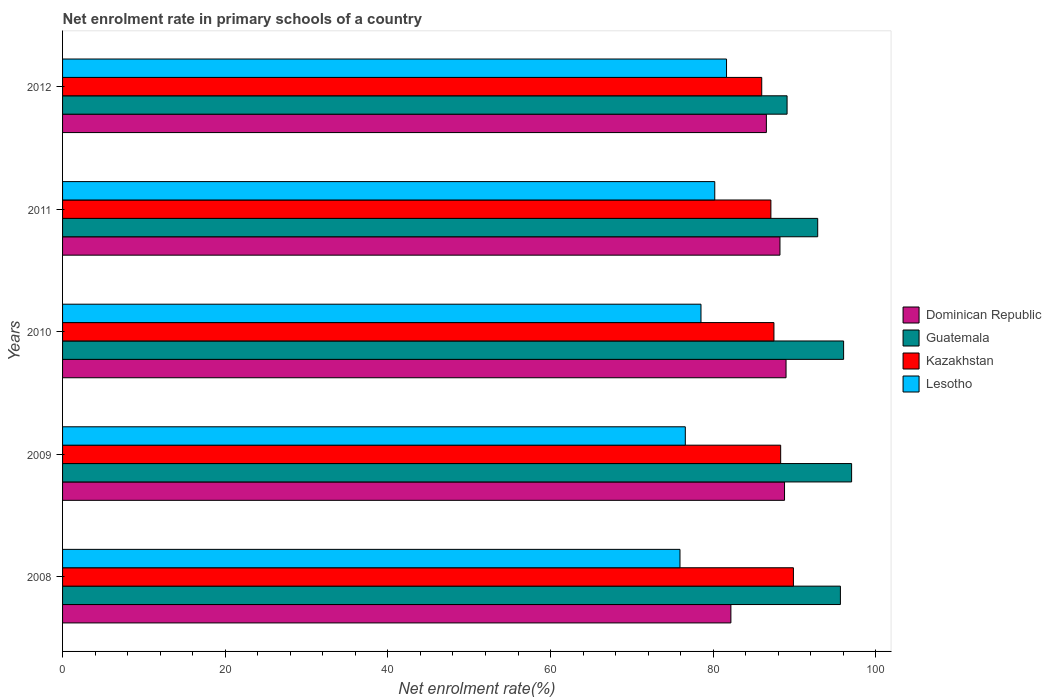How many different coloured bars are there?
Your response must be concise. 4. Are the number of bars on each tick of the Y-axis equal?
Keep it short and to the point. Yes. How many bars are there on the 1st tick from the top?
Your response must be concise. 4. How many bars are there on the 2nd tick from the bottom?
Your response must be concise. 4. In how many cases, is the number of bars for a given year not equal to the number of legend labels?
Offer a very short reply. 0. What is the net enrolment rate in primary schools in Lesotho in 2011?
Ensure brevity in your answer.  80.19. Across all years, what is the maximum net enrolment rate in primary schools in Guatemala?
Your answer should be very brief. 97.01. Across all years, what is the minimum net enrolment rate in primary schools in Guatemala?
Give a very brief answer. 89.08. What is the total net enrolment rate in primary schools in Guatemala in the graph?
Offer a very short reply. 470.59. What is the difference between the net enrolment rate in primary schools in Lesotho in 2010 and that in 2011?
Your answer should be compact. -1.69. What is the difference between the net enrolment rate in primary schools in Kazakhstan in 2011 and the net enrolment rate in primary schools in Lesotho in 2012?
Make the answer very short. 5.45. What is the average net enrolment rate in primary schools in Dominican Republic per year?
Your answer should be very brief. 86.92. In the year 2012, what is the difference between the net enrolment rate in primary schools in Guatemala and net enrolment rate in primary schools in Dominican Republic?
Ensure brevity in your answer.  2.55. In how many years, is the net enrolment rate in primary schools in Lesotho greater than 20 %?
Provide a succinct answer. 5. What is the ratio of the net enrolment rate in primary schools in Kazakhstan in 2008 to that in 2012?
Give a very brief answer. 1.05. Is the net enrolment rate in primary schools in Kazakhstan in 2010 less than that in 2011?
Make the answer very short. No. Is the difference between the net enrolment rate in primary schools in Guatemala in 2008 and 2011 greater than the difference between the net enrolment rate in primary schools in Dominican Republic in 2008 and 2011?
Ensure brevity in your answer.  Yes. What is the difference between the highest and the second highest net enrolment rate in primary schools in Lesotho?
Your response must be concise. 1.45. What is the difference between the highest and the lowest net enrolment rate in primary schools in Lesotho?
Ensure brevity in your answer.  5.72. Is the sum of the net enrolment rate in primary schools in Kazakhstan in 2010 and 2012 greater than the maximum net enrolment rate in primary schools in Guatemala across all years?
Keep it short and to the point. Yes. What does the 4th bar from the top in 2010 represents?
Provide a short and direct response. Dominican Republic. What does the 2nd bar from the bottom in 2010 represents?
Give a very brief answer. Guatemala. How many bars are there?
Make the answer very short. 20. How many years are there in the graph?
Offer a terse response. 5. Does the graph contain any zero values?
Give a very brief answer. No. Does the graph contain grids?
Keep it short and to the point. No. Where does the legend appear in the graph?
Your answer should be compact. Center right. How are the legend labels stacked?
Your response must be concise. Vertical. What is the title of the graph?
Keep it short and to the point. Net enrolment rate in primary schools of a country. What is the label or title of the X-axis?
Your answer should be compact. Net enrolment rate(%). What is the label or title of the Y-axis?
Keep it short and to the point. Years. What is the Net enrolment rate(%) in Dominican Republic in 2008?
Offer a terse response. 82.17. What is the Net enrolment rate(%) of Guatemala in 2008?
Ensure brevity in your answer.  95.63. What is the Net enrolment rate(%) in Kazakhstan in 2008?
Your answer should be compact. 89.86. What is the Net enrolment rate(%) of Lesotho in 2008?
Make the answer very short. 75.91. What is the Net enrolment rate(%) in Dominican Republic in 2009?
Ensure brevity in your answer.  88.76. What is the Net enrolment rate(%) in Guatemala in 2009?
Provide a short and direct response. 97.01. What is the Net enrolment rate(%) in Kazakhstan in 2009?
Provide a succinct answer. 88.29. What is the Net enrolment rate(%) of Lesotho in 2009?
Keep it short and to the point. 76.57. What is the Net enrolment rate(%) in Dominican Republic in 2010?
Offer a terse response. 88.95. What is the Net enrolment rate(%) of Guatemala in 2010?
Give a very brief answer. 96.03. What is the Net enrolment rate(%) in Kazakhstan in 2010?
Provide a succinct answer. 87.46. What is the Net enrolment rate(%) of Lesotho in 2010?
Your answer should be very brief. 78.49. What is the Net enrolment rate(%) of Dominican Republic in 2011?
Make the answer very short. 88.2. What is the Net enrolment rate(%) of Guatemala in 2011?
Keep it short and to the point. 92.84. What is the Net enrolment rate(%) of Kazakhstan in 2011?
Provide a short and direct response. 87.09. What is the Net enrolment rate(%) in Lesotho in 2011?
Your answer should be very brief. 80.19. What is the Net enrolment rate(%) in Dominican Republic in 2012?
Keep it short and to the point. 86.53. What is the Net enrolment rate(%) in Guatemala in 2012?
Your answer should be very brief. 89.08. What is the Net enrolment rate(%) in Kazakhstan in 2012?
Offer a terse response. 85.96. What is the Net enrolment rate(%) in Lesotho in 2012?
Offer a terse response. 81.63. Across all years, what is the maximum Net enrolment rate(%) in Dominican Republic?
Offer a very short reply. 88.95. Across all years, what is the maximum Net enrolment rate(%) of Guatemala?
Your answer should be very brief. 97.01. Across all years, what is the maximum Net enrolment rate(%) of Kazakhstan?
Your response must be concise. 89.86. Across all years, what is the maximum Net enrolment rate(%) of Lesotho?
Offer a very short reply. 81.63. Across all years, what is the minimum Net enrolment rate(%) of Dominican Republic?
Offer a very short reply. 82.17. Across all years, what is the minimum Net enrolment rate(%) in Guatemala?
Your answer should be very brief. 89.08. Across all years, what is the minimum Net enrolment rate(%) of Kazakhstan?
Ensure brevity in your answer.  85.96. Across all years, what is the minimum Net enrolment rate(%) in Lesotho?
Offer a very short reply. 75.91. What is the total Net enrolment rate(%) of Dominican Republic in the graph?
Your answer should be very brief. 434.62. What is the total Net enrolment rate(%) in Guatemala in the graph?
Offer a terse response. 470.59. What is the total Net enrolment rate(%) in Kazakhstan in the graph?
Ensure brevity in your answer.  438.65. What is the total Net enrolment rate(%) of Lesotho in the graph?
Keep it short and to the point. 392.79. What is the difference between the Net enrolment rate(%) in Dominican Republic in 2008 and that in 2009?
Keep it short and to the point. -6.6. What is the difference between the Net enrolment rate(%) in Guatemala in 2008 and that in 2009?
Offer a terse response. -1.38. What is the difference between the Net enrolment rate(%) in Kazakhstan in 2008 and that in 2009?
Your answer should be compact. 1.57. What is the difference between the Net enrolment rate(%) of Lesotho in 2008 and that in 2009?
Provide a succinct answer. -0.65. What is the difference between the Net enrolment rate(%) in Dominican Republic in 2008 and that in 2010?
Provide a succinct answer. -6.78. What is the difference between the Net enrolment rate(%) of Guatemala in 2008 and that in 2010?
Provide a succinct answer. -0.39. What is the difference between the Net enrolment rate(%) of Kazakhstan in 2008 and that in 2010?
Keep it short and to the point. 2.4. What is the difference between the Net enrolment rate(%) of Lesotho in 2008 and that in 2010?
Give a very brief answer. -2.58. What is the difference between the Net enrolment rate(%) in Dominican Republic in 2008 and that in 2011?
Ensure brevity in your answer.  -6.03. What is the difference between the Net enrolment rate(%) in Guatemala in 2008 and that in 2011?
Give a very brief answer. 2.79. What is the difference between the Net enrolment rate(%) in Kazakhstan in 2008 and that in 2011?
Give a very brief answer. 2.77. What is the difference between the Net enrolment rate(%) in Lesotho in 2008 and that in 2011?
Provide a short and direct response. -4.28. What is the difference between the Net enrolment rate(%) in Dominican Republic in 2008 and that in 2012?
Keep it short and to the point. -4.36. What is the difference between the Net enrolment rate(%) of Guatemala in 2008 and that in 2012?
Your answer should be very brief. 6.56. What is the difference between the Net enrolment rate(%) in Kazakhstan in 2008 and that in 2012?
Give a very brief answer. 3.9. What is the difference between the Net enrolment rate(%) of Lesotho in 2008 and that in 2012?
Provide a short and direct response. -5.72. What is the difference between the Net enrolment rate(%) of Dominican Republic in 2009 and that in 2010?
Offer a terse response. -0.19. What is the difference between the Net enrolment rate(%) of Guatemala in 2009 and that in 2010?
Offer a very short reply. 0.98. What is the difference between the Net enrolment rate(%) in Kazakhstan in 2009 and that in 2010?
Your response must be concise. 0.83. What is the difference between the Net enrolment rate(%) of Lesotho in 2009 and that in 2010?
Offer a very short reply. -1.93. What is the difference between the Net enrolment rate(%) of Dominican Republic in 2009 and that in 2011?
Your answer should be compact. 0.56. What is the difference between the Net enrolment rate(%) of Guatemala in 2009 and that in 2011?
Your answer should be compact. 4.17. What is the difference between the Net enrolment rate(%) of Kazakhstan in 2009 and that in 2011?
Give a very brief answer. 1.2. What is the difference between the Net enrolment rate(%) of Lesotho in 2009 and that in 2011?
Offer a terse response. -3.62. What is the difference between the Net enrolment rate(%) of Dominican Republic in 2009 and that in 2012?
Keep it short and to the point. 2.23. What is the difference between the Net enrolment rate(%) in Guatemala in 2009 and that in 2012?
Provide a short and direct response. 7.93. What is the difference between the Net enrolment rate(%) in Kazakhstan in 2009 and that in 2012?
Your answer should be very brief. 2.33. What is the difference between the Net enrolment rate(%) of Lesotho in 2009 and that in 2012?
Your answer should be compact. -5.07. What is the difference between the Net enrolment rate(%) in Dominican Republic in 2010 and that in 2011?
Your answer should be very brief. 0.75. What is the difference between the Net enrolment rate(%) of Guatemala in 2010 and that in 2011?
Your response must be concise. 3.19. What is the difference between the Net enrolment rate(%) of Kazakhstan in 2010 and that in 2011?
Make the answer very short. 0.37. What is the difference between the Net enrolment rate(%) of Lesotho in 2010 and that in 2011?
Your answer should be very brief. -1.69. What is the difference between the Net enrolment rate(%) in Dominican Republic in 2010 and that in 2012?
Keep it short and to the point. 2.42. What is the difference between the Net enrolment rate(%) of Guatemala in 2010 and that in 2012?
Your answer should be compact. 6.95. What is the difference between the Net enrolment rate(%) in Kazakhstan in 2010 and that in 2012?
Keep it short and to the point. 1.5. What is the difference between the Net enrolment rate(%) in Lesotho in 2010 and that in 2012?
Provide a succinct answer. -3.14. What is the difference between the Net enrolment rate(%) of Dominican Republic in 2011 and that in 2012?
Offer a very short reply. 1.67. What is the difference between the Net enrolment rate(%) of Guatemala in 2011 and that in 2012?
Provide a succinct answer. 3.76. What is the difference between the Net enrolment rate(%) of Kazakhstan in 2011 and that in 2012?
Keep it short and to the point. 1.13. What is the difference between the Net enrolment rate(%) in Lesotho in 2011 and that in 2012?
Provide a succinct answer. -1.45. What is the difference between the Net enrolment rate(%) of Dominican Republic in 2008 and the Net enrolment rate(%) of Guatemala in 2009?
Offer a very short reply. -14.84. What is the difference between the Net enrolment rate(%) in Dominican Republic in 2008 and the Net enrolment rate(%) in Kazakhstan in 2009?
Give a very brief answer. -6.12. What is the difference between the Net enrolment rate(%) of Dominican Republic in 2008 and the Net enrolment rate(%) of Lesotho in 2009?
Ensure brevity in your answer.  5.6. What is the difference between the Net enrolment rate(%) in Guatemala in 2008 and the Net enrolment rate(%) in Kazakhstan in 2009?
Your answer should be compact. 7.34. What is the difference between the Net enrolment rate(%) of Guatemala in 2008 and the Net enrolment rate(%) of Lesotho in 2009?
Offer a terse response. 19.07. What is the difference between the Net enrolment rate(%) of Kazakhstan in 2008 and the Net enrolment rate(%) of Lesotho in 2009?
Ensure brevity in your answer.  13.29. What is the difference between the Net enrolment rate(%) in Dominican Republic in 2008 and the Net enrolment rate(%) in Guatemala in 2010?
Your response must be concise. -13.86. What is the difference between the Net enrolment rate(%) of Dominican Republic in 2008 and the Net enrolment rate(%) of Kazakhstan in 2010?
Offer a terse response. -5.29. What is the difference between the Net enrolment rate(%) of Dominican Republic in 2008 and the Net enrolment rate(%) of Lesotho in 2010?
Ensure brevity in your answer.  3.68. What is the difference between the Net enrolment rate(%) in Guatemala in 2008 and the Net enrolment rate(%) in Kazakhstan in 2010?
Make the answer very short. 8.17. What is the difference between the Net enrolment rate(%) in Guatemala in 2008 and the Net enrolment rate(%) in Lesotho in 2010?
Your answer should be very brief. 17.14. What is the difference between the Net enrolment rate(%) of Kazakhstan in 2008 and the Net enrolment rate(%) of Lesotho in 2010?
Provide a succinct answer. 11.36. What is the difference between the Net enrolment rate(%) in Dominican Republic in 2008 and the Net enrolment rate(%) in Guatemala in 2011?
Keep it short and to the point. -10.67. What is the difference between the Net enrolment rate(%) of Dominican Republic in 2008 and the Net enrolment rate(%) of Kazakhstan in 2011?
Keep it short and to the point. -4.92. What is the difference between the Net enrolment rate(%) of Dominican Republic in 2008 and the Net enrolment rate(%) of Lesotho in 2011?
Keep it short and to the point. 1.98. What is the difference between the Net enrolment rate(%) in Guatemala in 2008 and the Net enrolment rate(%) in Kazakhstan in 2011?
Offer a terse response. 8.55. What is the difference between the Net enrolment rate(%) in Guatemala in 2008 and the Net enrolment rate(%) in Lesotho in 2011?
Provide a short and direct response. 15.45. What is the difference between the Net enrolment rate(%) in Kazakhstan in 2008 and the Net enrolment rate(%) in Lesotho in 2011?
Give a very brief answer. 9.67. What is the difference between the Net enrolment rate(%) in Dominican Republic in 2008 and the Net enrolment rate(%) in Guatemala in 2012?
Offer a very short reply. -6.91. What is the difference between the Net enrolment rate(%) of Dominican Republic in 2008 and the Net enrolment rate(%) of Kazakhstan in 2012?
Give a very brief answer. -3.79. What is the difference between the Net enrolment rate(%) in Dominican Republic in 2008 and the Net enrolment rate(%) in Lesotho in 2012?
Offer a very short reply. 0.53. What is the difference between the Net enrolment rate(%) of Guatemala in 2008 and the Net enrolment rate(%) of Kazakhstan in 2012?
Your answer should be very brief. 9.67. What is the difference between the Net enrolment rate(%) in Guatemala in 2008 and the Net enrolment rate(%) in Lesotho in 2012?
Your response must be concise. 14. What is the difference between the Net enrolment rate(%) of Kazakhstan in 2008 and the Net enrolment rate(%) of Lesotho in 2012?
Ensure brevity in your answer.  8.22. What is the difference between the Net enrolment rate(%) of Dominican Republic in 2009 and the Net enrolment rate(%) of Guatemala in 2010?
Give a very brief answer. -7.26. What is the difference between the Net enrolment rate(%) of Dominican Republic in 2009 and the Net enrolment rate(%) of Kazakhstan in 2010?
Provide a short and direct response. 1.3. What is the difference between the Net enrolment rate(%) in Dominican Republic in 2009 and the Net enrolment rate(%) in Lesotho in 2010?
Give a very brief answer. 10.27. What is the difference between the Net enrolment rate(%) of Guatemala in 2009 and the Net enrolment rate(%) of Kazakhstan in 2010?
Make the answer very short. 9.55. What is the difference between the Net enrolment rate(%) of Guatemala in 2009 and the Net enrolment rate(%) of Lesotho in 2010?
Your answer should be compact. 18.52. What is the difference between the Net enrolment rate(%) in Kazakhstan in 2009 and the Net enrolment rate(%) in Lesotho in 2010?
Your answer should be compact. 9.8. What is the difference between the Net enrolment rate(%) in Dominican Republic in 2009 and the Net enrolment rate(%) in Guatemala in 2011?
Provide a short and direct response. -4.08. What is the difference between the Net enrolment rate(%) in Dominican Republic in 2009 and the Net enrolment rate(%) in Kazakhstan in 2011?
Make the answer very short. 1.68. What is the difference between the Net enrolment rate(%) of Dominican Republic in 2009 and the Net enrolment rate(%) of Lesotho in 2011?
Your answer should be compact. 8.58. What is the difference between the Net enrolment rate(%) of Guatemala in 2009 and the Net enrolment rate(%) of Kazakhstan in 2011?
Your response must be concise. 9.92. What is the difference between the Net enrolment rate(%) in Guatemala in 2009 and the Net enrolment rate(%) in Lesotho in 2011?
Offer a terse response. 16.82. What is the difference between the Net enrolment rate(%) of Kazakhstan in 2009 and the Net enrolment rate(%) of Lesotho in 2011?
Provide a short and direct response. 8.1. What is the difference between the Net enrolment rate(%) in Dominican Republic in 2009 and the Net enrolment rate(%) in Guatemala in 2012?
Offer a terse response. -0.31. What is the difference between the Net enrolment rate(%) in Dominican Republic in 2009 and the Net enrolment rate(%) in Kazakhstan in 2012?
Ensure brevity in your answer.  2.8. What is the difference between the Net enrolment rate(%) of Dominican Republic in 2009 and the Net enrolment rate(%) of Lesotho in 2012?
Give a very brief answer. 7.13. What is the difference between the Net enrolment rate(%) in Guatemala in 2009 and the Net enrolment rate(%) in Kazakhstan in 2012?
Your answer should be very brief. 11.05. What is the difference between the Net enrolment rate(%) of Guatemala in 2009 and the Net enrolment rate(%) of Lesotho in 2012?
Give a very brief answer. 15.38. What is the difference between the Net enrolment rate(%) in Kazakhstan in 2009 and the Net enrolment rate(%) in Lesotho in 2012?
Ensure brevity in your answer.  6.66. What is the difference between the Net enrolment rate(%) in Dominican Republic in 2010 and the Net enrolment rate(%) in Guatemala in 2011?
Offer a terse response. -3.89. What is the difference between the Net enrolment rate(%) in Dominican Republic in 2010 and the Net enrolment rate(%) in Kazakhstan in 2011?
Provide a succinct answer. 1.86. What is the difference between the Net enrolment rate(%) in Dominican Republic in 2010 and the Net enrolment rate(%) in Lesotho in 2011?
Make the answer very short. 8.76. What is the difference between the Net enrolment rate(%) in Guatemala in 2010 and the Net enrolment rate(%) in Kazakhstan in 2011?
Your answer should be very brief. 8.94. What is the difference between the Net enrolment rate(%) in Guatemala in 2010 and the Net enrolment rate(%) in Lesotho in 2011?
Your response must be concise. 15.84. What is the difference between the Net enrolment rate(%) in Kazakhstan in 2010 and the Net enrolment rate(%) in Lesotho in 2011?
Your answer should be compact. 7.27. What is the difference between the Net enrolment rate(%) in Dominican Republic in 2010 and the Net enrolment rate(%) in Guatemala in 2012?
Make the answer very short. -0.13. What is the difference between the Net enrolment rate(%) in Dominican Republic in 2010 and the Net enrolment rate(%) in Kazakhstan in 2012?
Give a very brief answer. 2.99. What is the difference between the Net enrolment rate(%) of Dominican Republic in 2010 and the Net enrolment rate(%) of Lesotho in 2012?
Offer a terse response. 7.32. What is the difference between the Net enrolment rate(%) in Guatemala in 2010 and the Net enrolment rate(%) in Kazakhstan in 2012?
Ensure brevity in your answer.  10.07. What is the difference between the Net enrolment rate(%) of Guatemala in 2010 and the Net enrolment rate(%) of Lesotho in 2012?
Your answer should be compact. 14.39. What is the difference between the Net enrolment rate(%) in Kazakhstan in 2010 and the Net enrolment rate(%) in Lesotho in 2012?
Provide a short and direct response. 5.83. What is the difference between the Net enrolment rate(%) in Dominican Republic in 2011 and the Net enrolment rate(%) in Guatemala in 2012?
Keep it short and to the point. -0.88. What is the difference between the Net enrolment rate(%) in Dominican Republic in 2011 and the Net enrolment rate(%) in Kazakhstan in 2012?
Ensure brevity in your answer.  2.24. What is the difference between the Net enrolment rate(%) of Dominican Republic in 2011 and the Net enrolment rate(%) of Lesotho in 2012?
Ensure brevity in your answer.  6.57. What is the difference between the Net enrolment rate(%) of Guatemala in 2011 and the Net enrolment rate(%) of Kazakhstan in 2012?
Your response must be concise. 6.88. What is the difference between the Net enrolment rate(%) in Guatemala in 2011 and the Net enrolment rate(%) in Lesotho in 2012?
Ensure brevity in your answer.  11.21. What is the difference between the Net enrolment rate(%) of Kazakhstan in 2011 and the Net enrolment rate(%) of Lesotho in 2012?
Your answer should be very brief. 5.45. What is the average Net enrolment rate(%) of Dominican Republic per year?
Your answer should be very brief. 86.92. What is the average Net enrolment rate(%) in Guatemala per year?
Make the answer very short. 94.12. What is the average Net enrolment rate(%) in Kazakhstan per year?
Offer a terse response. 87.73. What is the average Net enrolment rate(%) of Lesotho per year?
Your answer should be compact. 78.56. In the year 2008, what is the difference between the Net enrolment rate(%) of Dominican Republic and Net enrolment rate(%) of Guatemala?
Offer a terse response. -13.47. In the year 2008, what is the difference between the Net enrolment rate(%) of Dominican Republic and Net enrolment rate(%) of Kazakhstan?
Keep it short and to the point. -7.69. In the year 2008, what is the difference between the Net enrolment rate(%) in Dominican Republic and Net enrolment rate(%) in Lesotho?
Offer a very short reply. 6.26. In the year 2008, what is the difference between the Net enrolment rate(%) of Guatemala and Net enrolment rate(%) of Kazakhstan?
Your response must be concise. 5.78. In the year 2008, what is the difference between the Net enrolment rate(%) in Guatemala and Net enrolment rate(%) in Lesotho?
Your answer should be very brief. 19.72. In the year 2008, what is the difference between the Net enrolment rate(%) of Kazakhstan and Net enrolment rate(%) of Lesotho?
Your answer should be compact. 13.95. In the year 2009, what is the difference between the Net enrolment rate(%) of Dominican Republic and Net enrolment rate(%) of Guatemala?
Offer a very short reply. -8.25. In the year 2009, what is the difference between the Net enrolment rate(%) in Dominican Republic and Net enrolment rate(%) in Kazakhstan?
Give a very brief answer. 0.48. In the year 2009, what is the difference between the Net enrolment rate(%) in Dominican Republic and Net enrolment rate(%) in Lesotho?
Offer a terse response. 12.2. In the year 2009, what is the difference between the Net enrolment rate(%) in Guatemala and Net enrolment rate(%) in Kazakhstan?
Provide a succinct answer. 8.72. In the year 2009, what is the difference between the Net enrolment rate(%) of Guatemala and Net enrolment rate(%) of Lesotho?
Your answer should be compact. 20.44. In the year 2009, what is the difference between the Net enrolment rate(%) of Kazakhstan and Net enrolment rate(%) of Lesotho?
Your answer should be compact. 11.72. In the year 2010, what is the difference between the Net enrolment rate(%) in Dominican Republic and Net enrolment rate(%) in Guatemala?
Your answer should be very brief. -7.08. In the year 2010, what is the difference between the Net enrolment rate(%) of Dominican Republic and Net enrolment rate(%) of Kazakhstan?
Your answer should be very brief. 1.49. In the year 2010, what is the difference between the Net enrolment rate(%) in Dominican Republic and Net enrolment rate(%) in Lesotho?
Make the answer very short. 10.46. In the year 2010, what is the difference between the Net enrolment rate(%) in Guatemala and Net enrolment rate(%) in Kazakhstan?
Your answer should be compact. 8.57. In the year 2010, what is the difference between the Net enrolment rate(%) of Guatemala and Net enrolment rate(%) of Lesotho?
Offer a very short reply. 17.53. In the year 2010, what is the difference between the Net enrolment rate(%) in Kazakhstan and Net enrolment rate(%) in Lesotho?
Your response must be concise. 8.97. In the year 2011, what is the difference between the Net enrolment rate(%) in Dominican Republic and Net enrolment rate(%) in Guatemala?
Offer a very short reply. -4.64. In the year 2011, what is the difference between the Net enrolment rate(%) in Dominican Republic and Net enrolment rate(%) in Kazakhstan?
Make the answer very short. 1.12. In the year 2011, what is the difference between the Net enrolment rate(%) of Dominican Republic and Net enrolment rate(%) of Lesotho?
Keep it short and to the point. 8.02. In the year 2011, what is the difference between the Net enrolment rate(%) in Guatemala and Net enrolment rate(%) in Kazakhstan?
Your answer should be compact. 5.75. In the year 2011, what is the difference between the Net enrolment rate(%) of Guatemala and Net enrolment rate(%) of Lesotho?
Offer a very short reply. 12.65. In the year 2011, what is the difference between the Net enrolment rate(%) of Kazakhstan and Net enrolment rate(%) of Lesotho?
Ensure brevity in your answer.  6.9. In the year 2012, what is the difference between the Net enrolment rate(%) of Dominican Republic and Net enrolment rate(%) of Guatemala?
Offer a very short reply. -2.55. In the year 2012, what is the difference between the Net enrolment rate(%) in Dominican Republic and Net enrolment rate(%) in Kazakhstan?
Provide a succinct answer. 0.57. In the year 2012, what is the difference between the Net enrolment rate(%) of Dominican Republic and Net enrolment rate(%) of Lesotho?
Your answer should be very brief. 4.9. In the year 2012, what is the difference between the Net enrolment rate(%) in Guatemala and Net enrolment rate(%) in Kazakhstan?
Offer a terse response. 3.12. In the year 2012, what is the difference between the Net enrolment rate(%) in Guatemala and Net enrolment rate(%) in Lesotho?
Ensure brevity in your answer.  7.44. In the year 2012, what is the difference between the Net enrolment rate(%) in Kazakhstan and Net enrolment rate(%) in Lesotho?
Ensure brevity in your answer.  4.33. What is the ratio of the Net enrolment rate(%) in Dominican Republic in 2008 to that in 2009?
Make the answer very short. 0.93. What is the ratio of the Net enrolment rate(%) in Guatemala in 2008 to that in 2009?
Your response must be concise. 0.99. What is the ratio of the Net enrolment rate(%) in Kazakhstan in 2008 to that in 2009?
Provide a succinct answer. 1.02. What is the ratio of the Net enrolment rate(%) in Dominican Republic in 2008 to that in 2010?
Your answer should be compact. 0.92. What is the ratio of the Net enrolment rate(%) in Kazakhstan in 2008 to that in 2010?
Give a very brief answer. 1.03. What is the ratio of the Net enrolment rate(%) in Lesotho in 2008 to that in 2010?
Your answer should be very brief. 0.97. What is the ratio of the Net enrolment rate(%) in Dominican Republic in 2008 to that in 2011?
Offer a very short reply. 0.93. What is the ratio of the Net enrolment rate(%) in Guatemala in 2008 to that in 2011?
Your answer should be compact. 1.03. What is the ratio of the Net enrolment rate(%) in Kazakhstan in 2008 to that in 2011?
Offer a very short reply. 1.03. What is the ratio of the Net enrolment rate(%) of Lesotho in 2008 to that in 2011?
Your response must be concise. 0.95. What is the ratio of the Net enrolment rate(%) in Dominican Republic in 2008 to that in 2012?
Make the answer very short. 0.95. What is the ratio of the Net enrolment rate(%) in Guatemala in 2008 to that in 2012?
Your answer should be very brief. 1.07. What is the ratio of the Net enrolment rate(%) in Kazakhstan in 2008 to that in 2012?
Ensure brevity in your answer.  1.05. What is the ratio of the Net enrolment rate(%) of Lesotho in 2008 to that in 2012?
Ensure brevity in your answer.  0.93. What is the ratio of the Net enrolment rate(%) in Guatemala in 2009 to that in 2010?
Ensure brevity in your answer.  1.01. What is the ratio of the Net enrolment rate(%) of Kazakhstan in 2009 to that in 2010?
Offer a very short reply. 1.01. What is the ratio of the Net enrolment rate(%) of Lesotho in 2009 to that in 2010?
Your answer should be very brief. 0.98. What is the ratio of the Net enrolment rate(%) of Dominican Republic in 2009 to that in 2011?
Your answer should be very brief. 1.01. What is the ratio of the Net enrolment rate(%) of Guatemala in 2009 to that in 2011?
Your answer should be compact. 1.04. What is the ratio of the Net enrolment rate(%) in Kazakhstan in 2009 to that in 2011?
Your answer should be compact. 1.01. What is the ratio of the Net enrolment rate(%) of Lesotho in 2009 to that in 2011?
Keep it short and to the point. 0.95. What is the ratio of the Net enrolment rate(%) of Dominican Republic in 2009 to that in 2012?
Ensure brevity in your answer.  1.03. What is the ratio of the Net enrolment rate(%) in Guatemala in 2009 to that in 2012?
Give a very brief answer. 1.09. What is the ratio of the Net enrolment rate(%) in Kazakhstan in 2009 to that in 2012?
Your response must be concise. 1.03. What is the ratio of the Net enrolment rate(%) in Lesotho in 2009 to that in 2012?
Offer a terse response. 0.94. What is the ratio of the Net enrolment rate(%) of Dominican Republic in 2010 to that in 2011?
Your response must be concise. 1.01. What is the ratio of the Net enrolment rate(%) of Guatemala in 2010 to that in 2011?
Give a very brief answer. 1.03. What is the ratio of the Net enrolment rate(%) of Lesotho in 2010 to that in 2011?
Provide a succinct answer. 0.98. What is the ratio of the Net enrolment rate(%) of Dominican Republic in 2010 to that in 2012?
Offer a terse response. 1.03. What is the ratio of the Net enrolment rate(%) in Guatemala in 2010 to that in 2012?
Make the answer very short. 1.08. What is the ratio of the Net enrolment rate(%) of Kazakhstan in 2010 to that in 2012?
Make the answer very short. 1.02. What is the ratio of the Net enrolment rate(%) in Lesotho in 2010 to that in 2012?
Ensure brevity in your answer.  0.96. What is the ratio of the Net enrolment rate(%) of Dominican Republic in 2011 to that in 2012?
Ensure brevity in your answer.  1.02. What is the ratio of the Net enrolment rate(%) in Guatemala in 2011 to that in 2012?
Give a very brief answer. 1.04. What is the ratio of the Net enrolment rate(%) in Kazakhstan in 2011 to that in 2012?
Your answer should be compact. 1.01. What is the ratio of the Net enrolment rate(%) in Lesotho in 2011 to that in 2012?
Give a very brief answer. 0.98. What is the difference between the highest and the second highest Net enrolment rate(%) of Dominican Republic?
Ensure brevity in your answer.  0.19. What is the difference between the highest and the second highest Net enrolment rate(%) in Guatemala?
Provide a succinct answer. 0.98. What is the difference between the highest and the second highest Net enrolment rate(%) in Kazakhstan?
Make the answer very short. 1.57. What is the difference between the highest and the second highest Net enrolment rate(%) in Lesotho?
Offer a terse response. 1.45. What is the difference between the highest and the lowest Net enrolment rate(%) in Dominican Republic?
Your response must be concise. 6.78. What is the difference between the highest and the lowest Net enrolment rate(%) in Guatemala?
Ensure brevity in your answer.  7.93. What is the difference between the highest and the lowest Net enrolment rate(%) in Kazakhstan?
Offer a very short reply. 3.9. What is the difference between the highest and the lowest Net enrolment rate(%) in Lesotho?
Your response must be concise. 5.72. 